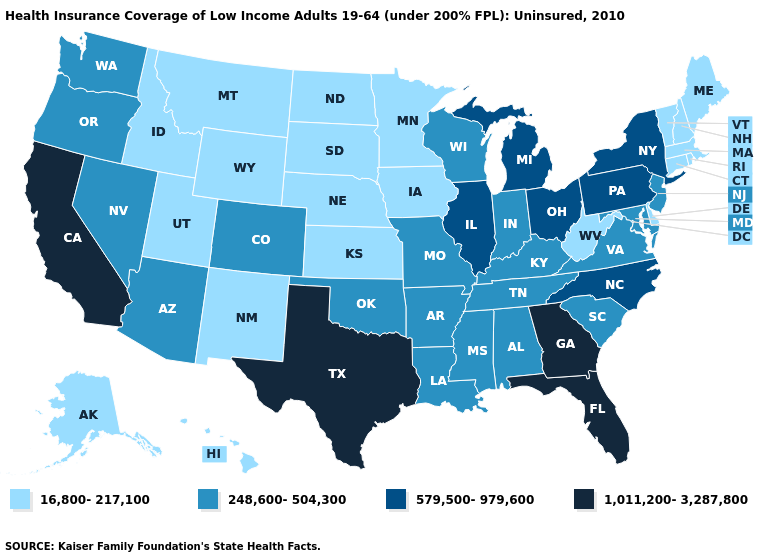Does Maine have a lower value than Kansas?
Write a very short answer. No. Does New Mexico have the same value as Oregon?
Answer briefly. No. What is the lowest value in the USA?
Short answer required. 16,800-217,100. Which states have the highest value in the USA?
Write a very short answer. California, Florida, Georgia, Texas. What is the value of Washington?
Answer briefly. 248,600-504,300. What is the value of Idaho?
Concise answer only. 16,800-217,100. What is the highest value in the MidWest ?
Quick response, please. 579,500-979,600. Name the states that have a value in the range 16,800-217,100?
Be succinct. Alaska, Connecticut, Delaware, Hawaii, Idaho, Iowa, Kansas, Maine, Massachusetts, Minnesota, Montana, Nebraska, New Hampshire, New Mexico, North Dakota, Rhode Island, South Dakota, Utah, Vermont, West Virginia, Wyoming. Is the legend a continuous bar?
Short answer required. No. What is the lowest value in the USA?
Keep it brief. 16,800-217,100. Name the states that have a value in the range 248,600-504,300?
Short answer required. Alabama, Arizona, Arkansas, Colorado, Indiana, Kentucky, Louisiana, Maryland, Mississippi, Missouri, Nevada, New Jersey, Oklahoma, Oregon, South Carolina, Tennessee, Virginia, Washington, Wisconsin. Does Maine have the lowest value in the USA?
Concise answer only. Yes. Does Rhode Island have the same value as Ohio?
Quick response, please. No. What is the value of Kansas?
Concise answer only. 16,800-217,100. 